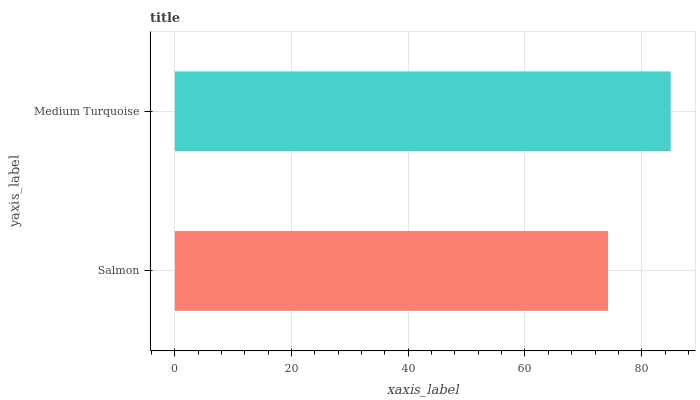Is Salmon the minimum?
Answer yes or no. Yes. Is Medium Turquoise the maximum?
Answer yes or no. Yes. Is Medium Turquoise the minimum?
Answer yes or no. No. Is Medium Turquoise greater than Salmon?
Answer yes or no. Yes. Is Salmon less than Medium Turquoise?
Answer yes or no. Yes. Is Salmon greater than Medium Turquoise?
Answer yes or no. No. Is Medium Turquoise less than Salmon?
Answer yes or no. No. Is Medium Turquoise the high median?
Answer yes or no. Yes. Is Salmon the low median?
Answer yes or no. Yes. Is Salmon the high median?
Answer yes or no. No. Is Medium Turquoise the low median?
Answer yes or no. No. 